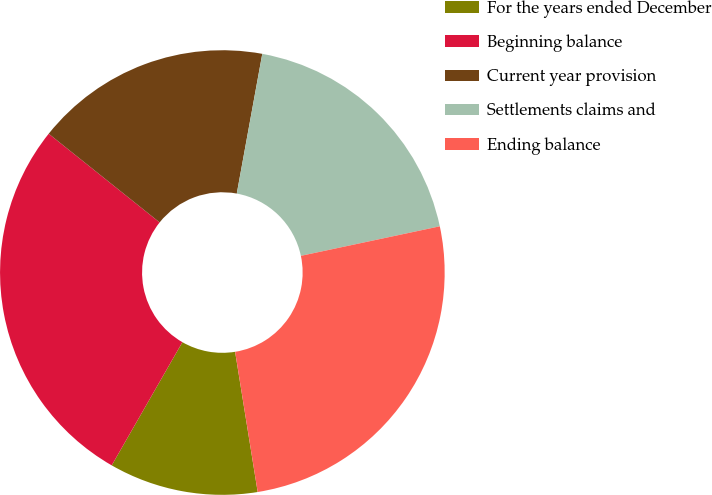Convert chart to OTSL. <chart><loc_0><loc_0><loc_500><loc_500><pie_chart><fcel>For the years ended December<fcel>Beginning balance<fcel>Current year provision<fcel>Settlements claims and<fcel>Ending balance<nl><fcel>10.83%<fcel>27.44%<fcel>17.14%<fcel>18.79%<fcel>25.79%<nl></chart> 